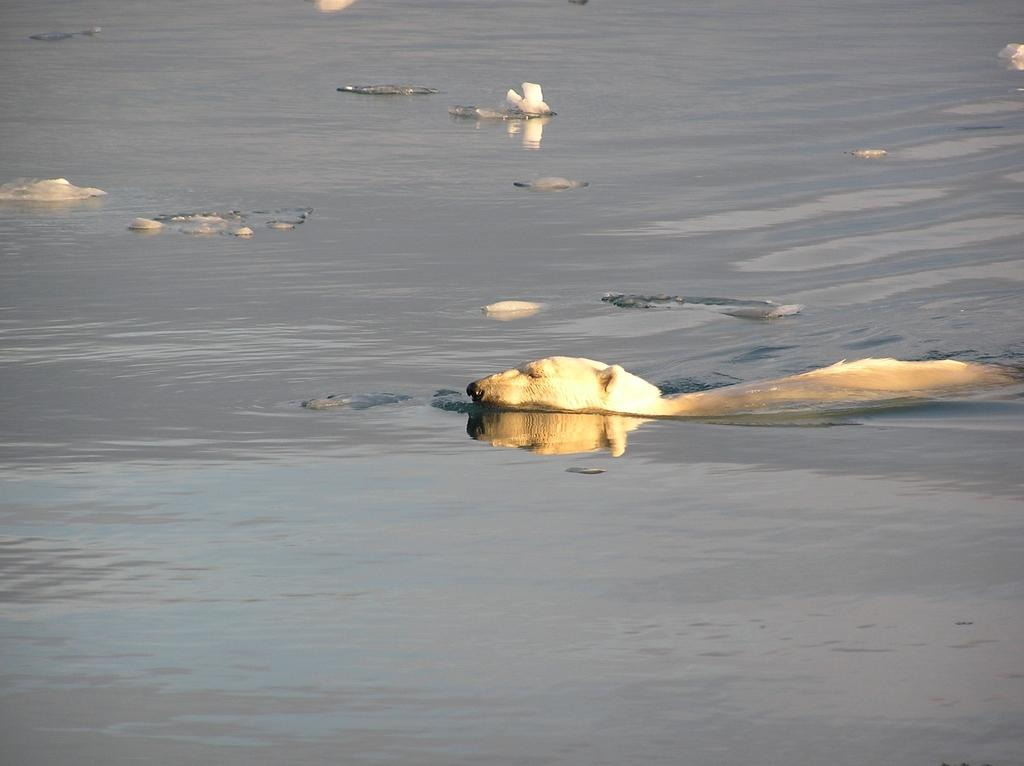What type of animals can be seen in the image? Animals can be seen in the water. Can you describe the setting where the animals are located? The animals are situated in the water. What type of battle is taking place in the image? There is no battle present in the image; it features animals in the water. Can you describe the kicking motion of the animals in the image? There is no kicking motion present in the image; the animals are simply in the water. 